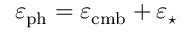Convert formula to latex. <formula><loc_0><loc_0><loc_500><loc_500>\varepsilon _ { p h } = \varepsilon _ { c m b } + \varepsilon _ { ^ { * } }</formula> 